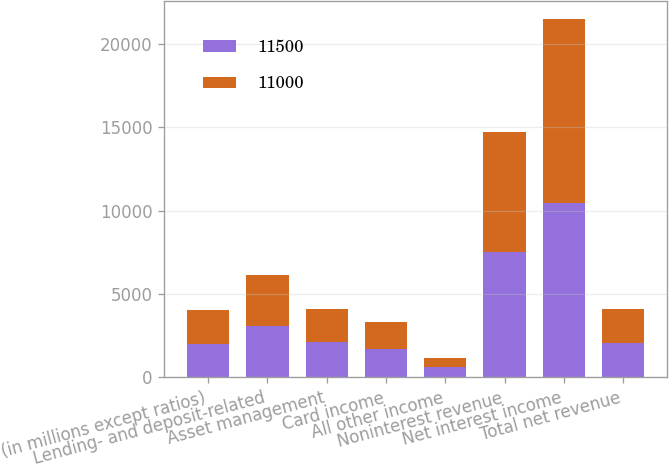<chart> <loc_0><loc_0><loc_500><loc_500><stacked_bar_chart><ecel><fcel>(in millions except ratios)<fcel>Lending- and deposit-related<fcel>Asset management<fcel>Card income<fcel>All other income<fcel>Noninterest revenue<fcel>Net interest income<fcel>Total net revenue<nl><fcel>11500<fcel>2015<fcel>3112<fcel>2097<fcel>1721<fcel>611<fcel>7541<fcel>10442<fcel>2061<nl><fcel>11000<fcel>2014<fcel>3010<fcel>2025<fcel>1605<fcel>534<fcel>7174<fcel>11052<fcel>2061<nl></chart> 